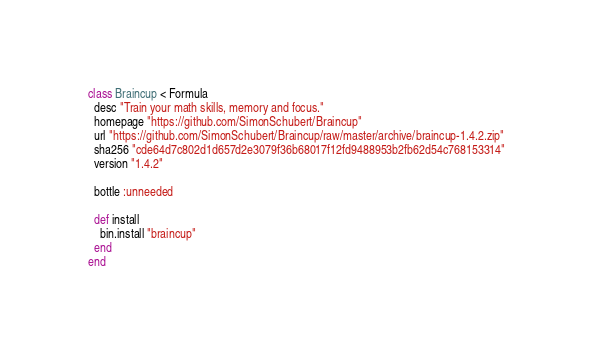<code> <loc_0><loc_0><loc_500><loc_500><_Ruby_>class Braincup < Formula
  desc "Train your math skills, memory and focus."
  homepage "https://github.com/SimonSchubert/Braincup"
  url "https://github.com/SimonSchubert/Braincup/raw/master/archive/braincup-1.4.2.zip"
  sha256 "cde64d7c802d1d657d2e3079f36b68017f12fd9488953b2fb62d54c768153314"
  version "1.4.2"

  bottle :unneeded

  def install
    bin.install "braincup"
  end
end
</code> 